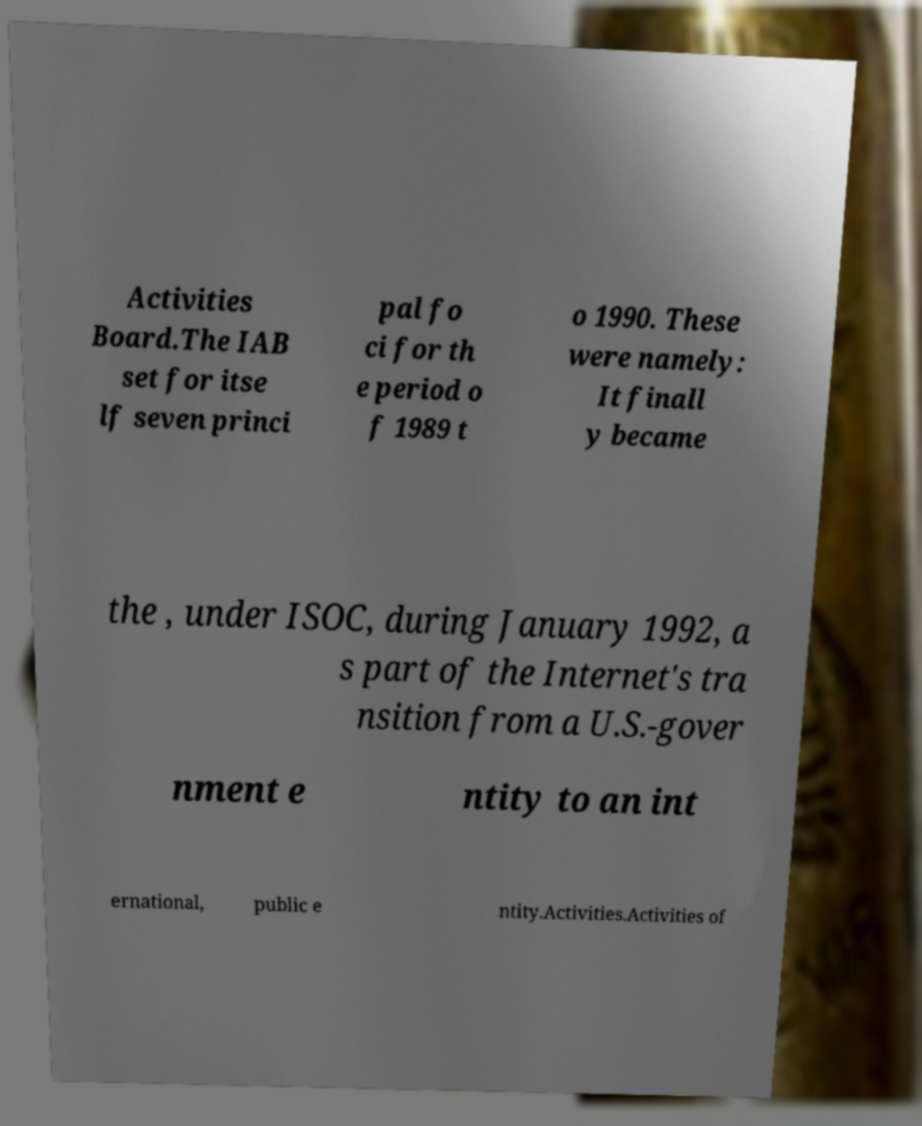Please identify and transcribe the text found in this image. Activities Board.The IAB set for itse lf seven princi pal fo ci for th e period o f 1989 t o 1990. These were namely: It finall y became the , under ISOC, during January 1992, a s part of the Internet's tra nsition from a U.S.-gover nment e ntity to an int ernational, public e ntity.Activities.Activities of 